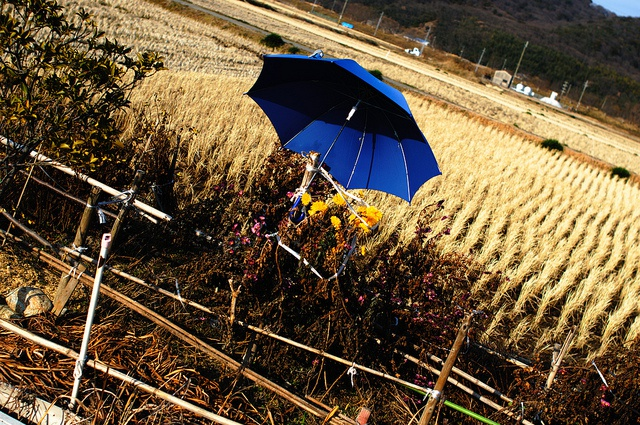Describe the objects in this image and their specific colors. I can see a umbrella in darkgreen, black, darkblue, navy, and blue tones in this image. 